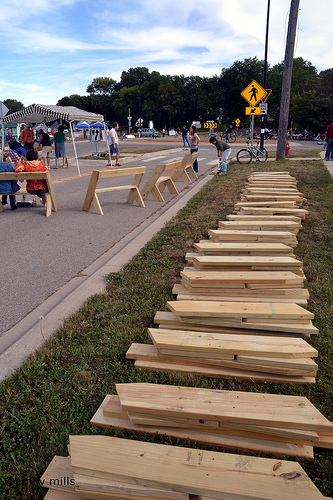<image>
Can you confirm if the arrow is behind the wood? Yes. From this viewpoint, the arrow is positioned behind the wood, with the wood partially or fully occluding the arrow. Where is the sign in relation to the bicycle? Is it next to the bicycle? Yes. The sign is positioned adjacent to the bicycle, located nearby in the same general area. 